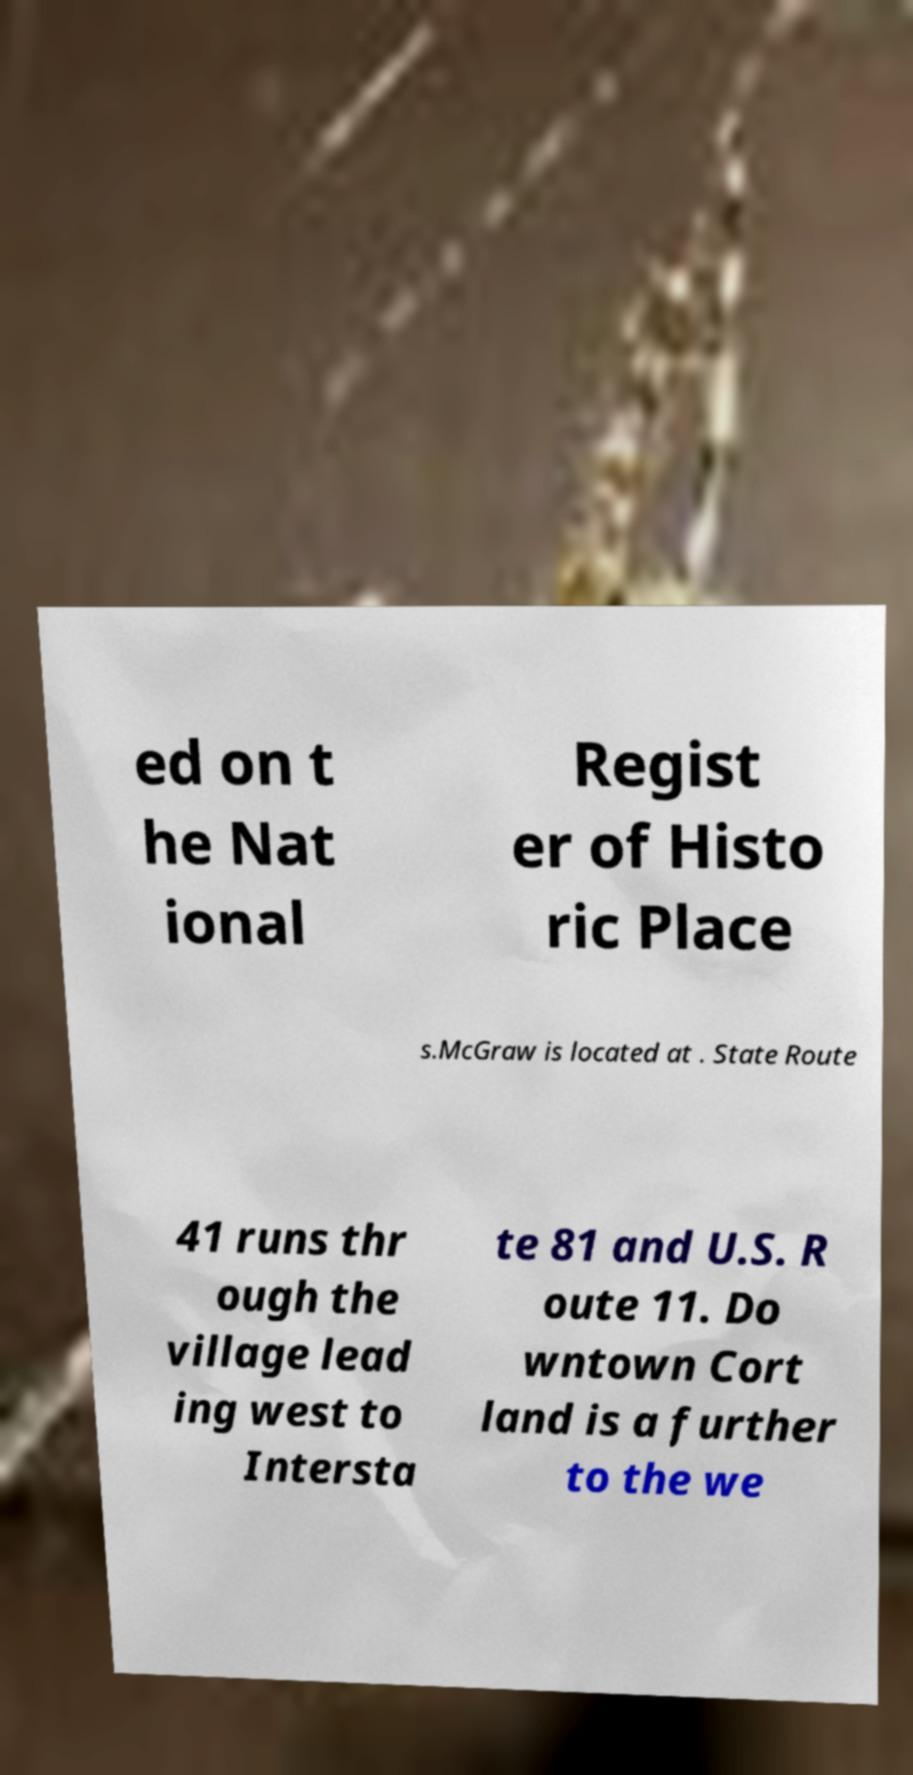Could you extract and type out the text from this image? ed on t he Nat ional Regist er of Histo ric Place s.McGraw is located at . State Route 41 runs thr ough the village lead ing west to Intersta te 81 and U.S. R oute 11. Do wntown Cort land is a further to the we 